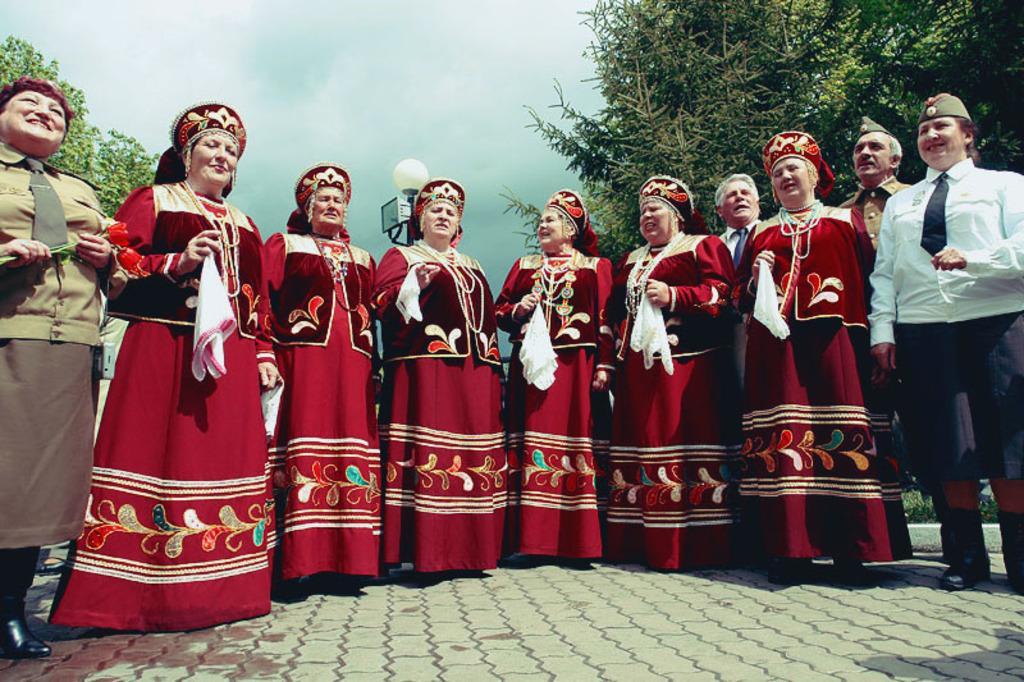In one or two sentences, can you explain what this image depicts? In this image I see people who are standing on path and I see that these women are wearing same dress and holding a white cloth in their hands and I see that these 2 women are smiling. In the background I see the trees, a light on this pole and I see the sky. 